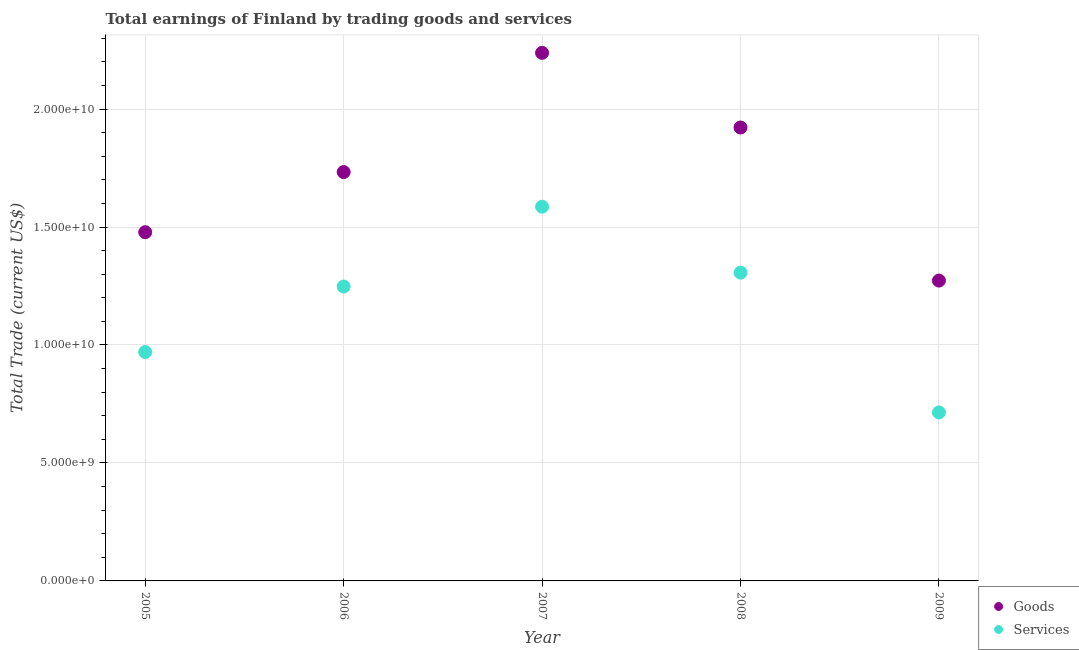What is the amount earned by trading services in 2009?
Keep it short and to the point. 7.14e+09. Across all years, what is the maximum amount earned by trading services?
Offer a terse response. 1.59e+1. Across all years, what is the minimum amount earned by trading goods?
Your answer should be very brief. 1.27e+1. In which year was the amount earned by trading goods minimum?
Keep it short and to the point. 2009. What is the total amount earned by trading goods in the graph?
Your response must be concise. 8.64e+1. What is the difference between the amount earned by trading services in 2005 and that in 2008?
Your answer should be compact. -3.36e+09. What is the difference between the amount earned by trading goods in 2007 and the amount earned by trading services in 2005?
Your answer should be compact. 1.27e+1. What is the average amount earned by trading goods per year?
Offer a very short reply. 1.73e+1. In the year 2005, what is the difference between the amount earned by trading goods and amount earned by trading services?
Ensure brevity in your answer.  5.08e+09. In how many years, is the amount earned by trading goods greater than 2000000000 US$?
Offer a very short reply. 5. What is the ratio of the amount earned by trading services in 2008 to that in 2009?
Your response must be concise. 1.83. Is the amount earned by trading services in 2005 less than that in 2007?
Give a very brief answer. Yes. Is the difference between the amount earned by trading services in 2005 and 2006 greater than the difference between the amount earned by trading goods in 2005 and 2006?
Make the answer very short. No. What is the difference between the highest and the second highest amount earned by trading services?
Your answer should be compact. 2.79e+09. What is the difference between the highest and the lowest amount earned by trading services?
Your response must be concise. 8.72e+09. In how many years, is the amount earned by trading services greater than the average amount earned by trading services taken over all years?
Provide a short and direct response. 3. Does the amount earned by trading goods monotonically increase over the years?
Offer a very short reply. No. Is the amount earned by trading services strictly greater than the amount earned by trading goods over the years?
Provide a short and direct response. No. How many dotlines are there?
Your answer should be very brief. 2. How many years are there in the graph?
Offer a terse response. 5. Are the values on the major ticks of Y-axis written in scientific E-notation?
Offer a very short reply. Yes. Does the graph contain any zero values?
Give a very brief answer. No. Where does the legend appear in the graph?
Your response must be concise. Bottom right. How many legend labels are there?
Give a very brief answer. 2. What is the title of the graph?
Offer a terse response. Total earnings of Finland by trading goods and services. What is the label or title of the X-axis?
Offer a terse response. Year. What is the label or title of the Y-axis?
Ensure brevity in your answer.  Total Trade (current US$). What is the Total Trade (current US$) of Goods in 2005?
Provide a short and direct response. 1.48e+1. What is the Total Trade (current US$) in Services in 2005?
Your answer should be very brief. 9.70e+09. What is the Total Trade (current US$) of Goods in 2006?
Give a very brief answer. 1.73e+1. What is the Total Trade (current US$) of Services in 2006?
Provide a short and direct response. 1.25e+1. What is the Total Trade (current US$) in Goods in 2007?
Your answer should be very brief. 2.24e+1. What is the Total Trade (current US$) of Services in 2007?
Offer a very short reply. 1.59e+1. What is the Total Trade (current US$) in Goods in 2008?
Your response must be concise. 1.92e+1. What is the Total Trade (current US$) in Services in 2008?
Your answer should be compact. 1.31e+1. What is the Total Trade (current US$) of Goods in 2009?
Your response must be concise. 1.27e+1. What is the Total Trade (current US$) of Services in 2009?
Offer a terse response. 7.14e+09. Across all years, what is the maximum Total Trade (current US$) in Goods?
Your answer should be very brief. 2.24e+1. Across all years, what is the maximum Total Trade (current US$) of Services?
Your response must be concise. 1.59e+1. Across all years, what is the minimum Total Trade (current US$) in Goods?
Offer a terse response. 1.27e+1. Across all years, what is the minimum Total Trade (current US$) of Services?
Provide a short and direct response. 7.14e+09. What is the total Total Trade (current US$) in Goods in the graph?
Provide a short and direct response. 8.64e+1. What is the total Total Trade (current US$) in Services in the graph?
Provide a succinct answer. 5.82e+1. What is the difference between the Total Trade (current US$) of Goods in 2005 and that in 2006?
Your response must be concise. -2.55e+09. What is the difference between the Total Trade (current US$) in Services in 2005 and that in 2006?
Make the answer very short. -2.78e+09. What is the difference between the Total Trade (current US$) in Goods in 2005 and that in 2007?
Make the answer very short. -7.60e+09. What is the difference between the Total Trade (current US$) of Services in 2005 and that in 2007?
Keep it short and to the point. -6.16e+09. What is the difference between the Total Trade (current US$) in Goods in 2005 and that in 2008?
Ensure brevity in your answer.  -4.44e+09. What is the difference between the Total Trade (current US$) of Services in 2005 and that in 2008?
Keep it short and to the point. -3.36e+09. What is the difference between the Total Trade (current US$) in Goods in 2005 and that in 2009?
Your answer should be compact. 2.05e+09. What is the difference between the Total Trade (current US$) of Services in 2005 and that in 2009?
Offer a very short reply. 2.56e+09. What is the difference between the Total Trade (current US$) in Goods in 2006 and that in 2007?
Ensure brevity in your answer.  -5.05e+09. What is the difference between the Total Trade (current US$) in Services in 2006 and that in 2007?
Give a very brief answer. -3.38e+09. What is the difference between the Total Trade (current US$) in Goods in 2006 and that in 2008?
Your answer should be very brief. -1.89e+09. What is the difference between the Total Trade (current US$) in Services in 2006 and that in 2008?
Your answer should be compact. -5.88e+08. What is the difference between the Total Trade (current US$) in Goods in 2006 and that in 2009?
Provide a short and direct response. 4.60e+09. What is the difference between the Total Trade (current US$) in Services in 2006 and that in 2009?
Your response must be concise. 5.34e+09. What is the difference between the Total Trade (current US$) of Goods in 2007 and that in 2008?
Ensure brevity in your answer.  3.16e+09. What is the difference between the Total Trade (current US$) in Services in 2007 and that in 2008?
Ensure brevity in your answer.  2.79e+09. What is the difference between the Total Trade (current US$) in Goods in 2007 and that in 2009?
Make the answer very short. 9.65e+09. What is the difference between the Total Trade (current US$) of Services in 2007 and that in 2009?
Your answer should be compact. 8.72e+09. What is the difference between the Total Trade (current US$) in Goods in 2008 and that in 2009?
Offer a terse response. 6.49e+09. What is the difference between the Total Trade (current US$) of Services in 2008 and that in 2009?
Your answer should be very brief. 5.92e+09. What is the difference between the Total Trade (current US$) of Goods in 2005 and the Total Trade (current US$) of Services in 2006?
Your answer should be compact. 2.30e+09. What is the difference between the Total Trade (current US$) of Goods in 2005 and the Total Trade (current US$) of Services in 2007?
Give a very brief answer. -1.08e+09. What is the difference between the Total Trade (current US$) of Goods in 2005 and the Total Trade (current US$) of Services in 2008?
Keep it short and to the point. 1.71e+09. What is the difference between the Total Trade (current US$) of Goods in 2005 and the Total Trade (current US$) of Services in 2009?
Make the answer very short. 7.64e+09. What is the difference between the Total Trade (current US$) in Goods in 2006 and the Total Trade (current US$) in Services in 2007?
Provide a short and direct response. 1.47e+09. What is the difference between the Total Trade (current US$) in Goods in 2006 and the Total Trade (current US$) in Services in 2008?
Your response must be concise. 4.26e+09. What is the difference between the Total Trade (current US$) of Goods in 2006 and the Total Trade (current US$) of Services in 2009?
Give a very brief answer. 1.02e+1. What is the difference between the Total Trade (current US$) of Goods in 2007 and the Total Trade (current US$) of Services in 2008?
Ensure brevity in your answer.  9.32e+09. What is the difference between the Total Trade (current US$) of Goods in 2007 and the Total Trade (current US$) of Services in 2009?
Your answer should be compact. 1.52e+1. What is the difference between the Total Trade (current US$) of Goods in 2008 and the Total Trade (current US$) of Services in 2009?
Offer a very short reply. 1.21e+1. What is the average Total Trade (current US$) in Goods per year?
Your answer should be very brief. 1.73e+1. What is the average Total Trade (current US$) of Services per year?
Offer a very short reply. 1.16e+1. In the year 2005, what is the difference between the Total Trade (current US$) of Goods and Total Trade (current US$) of Services?
Offer a terse response. 5.08e+09. In the year 2006, what is the difference between the Total Trade (current US$) of Goods and Total Trade (current US$) of Services?
Provide a succinct answer. 4.85e+09. In the year 2007, what is the difference between the Total Trade (current US$) in Goods and Total Trade (current US$) in Services?
Give a very brief answer. 6.52e+09. In the year 2008, what is the difference between the Total Trade (current US$) of Goods and Total Trade (current US$) of Services?
Provide a succinct answer. 6.15e+09. In the year 2009, what is the difference between the Total Trade (current US$) of Goods and Total Trade (current US$) of Services?
Offer a terse response. 5.59e+09. What is the ratio of the Total Trade (current US$) of Goods in 2005 to that in 2006?
Your response must be concise. 0.85. What is the ratio of the Total Trade (current US$) in Services in 2005 to that in 2006?
Your response must be concise. 0.78. What is the ratio of the Total Trade (current US$) in Goods in 2005 to that in 2007?
Keep it short and to the point. 0.66. What is the ratio of the Total Trade (current US$) in Services in 2005 to that in 2007?
Offer a very short reply. 0.61. What is the ratio of the Total Trade (current US$) of Goods in 2005 to that in 2008?
Provide a short and direct response. 0.77. What is the ratio of the Total Trade (current US$) of Services in 2005 to that in 2008?
Your answer should be compact. 0.74. What is the ratio of the Total Trade (current US$) of Goods in 2005 to that in 2009?
Your response must be concise. 1.16. What is the ratio of the Total Trade (current US$) of Services in 2005 to that in 2009?
Provide a succinct answer. 1.36. What is the ratio of the Total Trade (current US$) of Goods in 2006 to that in 2007?
Your answer should be very brief. 0.77. What is the ratio of the Total Trade (current US$) in Services in 2006 to that in 2007?
Offer a very short reply. 0.79. What is the ratio of the Total Trade (current US$) in Goods in 2006 to that in 2008?
Provide a short and direct response. 0.9. What is the ratio of the Total Trade (current US$) in Services in 2006 to that in 2008?
Your answer should be compact. 0.95. What is the ratio of the Total Trade (current US$) in Goods in 2006 to that in 2009?
Your answer should be compact. 1.36. What is the ratio of the Total Trade (current US$) in Services in 2006 to that in 2009?
Give a very brief answer. 1.75. What is the ratio of the Total Trade (current US$) of Goods in 2007 to that in 2008?
Make the answer very short. 1.16. What is the ratio of the Total Trade (current US$) of Services in 2007 to that in 2008?
Your answer should be compact. 1.21. What is the ratio of the Total Trade (current US$) of Goods in 2007 to that in 2009?
Your answer should be compact. 1.76. What is the ratio of the Total Trade (current US$) of Services in 2007 to that in 2009?
Keep it short and to the point. 2.22. What is the ratio of the Total Trade (current US$) of Goods in 2008 to that in 2009?
Your answer should be compact. 1.51. What is the ratio of the Total Trade (current US$) in Services in 2008 to that in 2009?
Give a very brief answer. 1.83. What is the difference between the highest and the second highest Total Trade (current US$) of Goods?
Your answer should be very brief. 3.16e+09. What is the difference between the highest and the second highest Total Trade (current US$) in Services?
Your answer should be very brief. 2.79e+09. What is the difference between the highest and the lowest Total Trade (current US$) of Goods?
Your response must be concise. 9.65e+09. What is the difference between the highest and the lowest Total Trade (current US$) in Services?
Provide a short and direct response. 8.72e+09. 